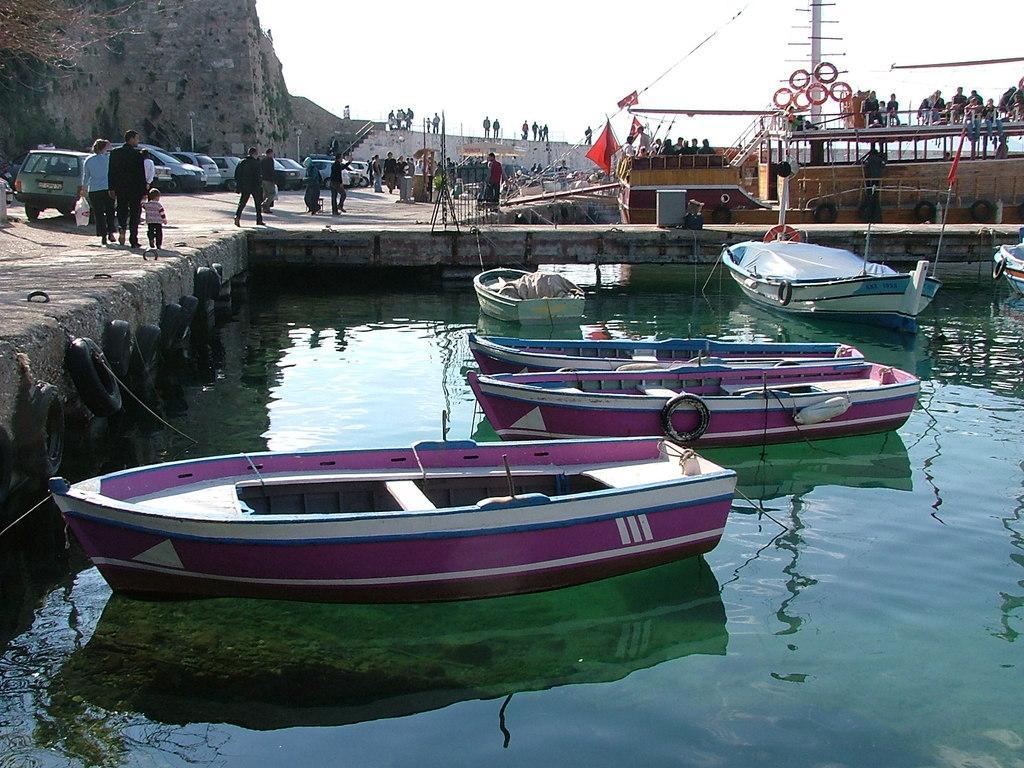In one or two sentences, can you explain what this image depicts? In the picture I can see a boats on the water. In the background I can see vehicles, people standing on the ground, boatyard, the sky and some other objects. 